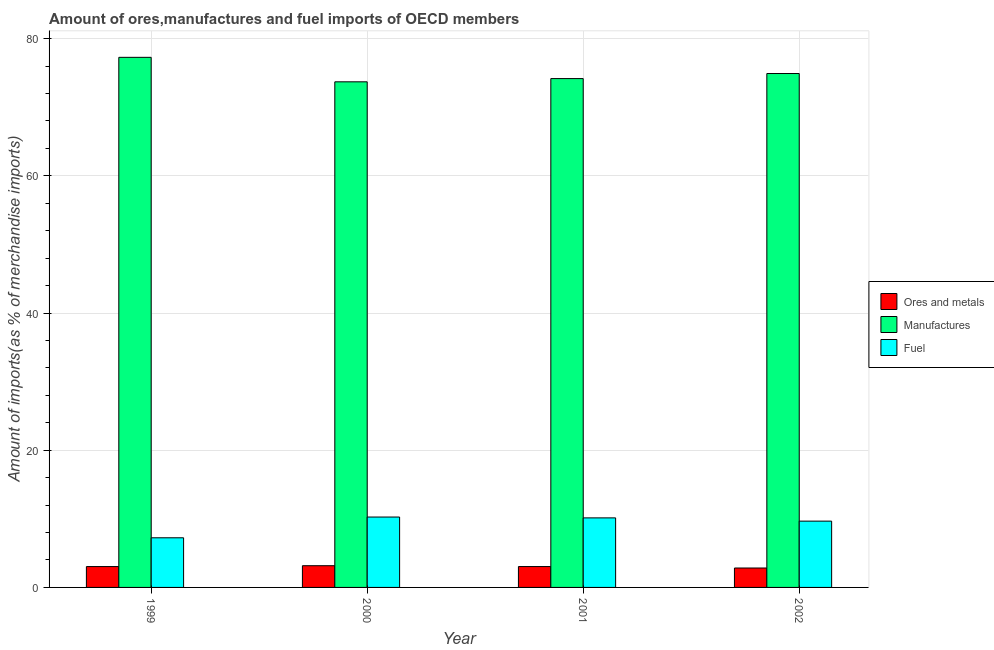How many groups of bars are there?
Offer a very short reply. 4. How many bars are there on the 4th tick from the left?
Give a very brief answer. 3. What is the label of the 2nd group of bars from the left?
Provide a short and direct response. 2000. What is the percentage of fuel imports in 2002?
Make the answer very short. 9.66. Across all years, what is the maximum percentage of manufactures imports?
Offer a terse response. 77.27. Across all years, what is the minimum percentage of manufactures imports?
Provide a short and direct response. 73.7. In which year was the percentage of ores and metals imports maximum?
Offer a terse response. 2000. In which year was the percentage of fuel imports minimum?
Give a very brief answer. 1999. What is the total percentage of manufactures imports in the graph?
Offer a very short reply. 300.05. What is the difference between the percentage of manufactures imports in 1999 and that in 2000?
Give a very brief answer. 3.57. What is the difference between the percentage of manufactures imports in 1999 and the percentage of fuel imports in 2000?
Provide a succinct answer. 3.57. What is the average percentage of manufactures imports per year?
Your answer should be very brief. 75.01. What is the ratio of the percentage of ores and metals imports in 2000 to that in 2001?
Ensure brevity in your answer.  1.04. What is the difference between the highest and the second highest percentage of fuel imports?
Give a very brief answer. 0.12. What is the difference between the highest and the lowest percentage of ores and metals imports?
Provide a succinct answer. 0.34. Is the sum of the percentage of manufactures imports in 2000 and 2001 greater than the maximum percentage of ores and metals imports across all years?
Provide a succinct answer. Yes. What does the 3rd bar from the left in 1999 represents?
Your response must be concise. Fuel. What does the 2nd bar from the right in 2002 represents?
Offer a terse response. Manufactures. How many bars are there?
Provide a succinct answer. 12. Are all the bars in the graph horizontal?
Keep it short and to the point. No. How many years are there in the graph?
Your response must be concise. 4. What is the difference between two consecutive major ticks on the Y-axis?
Provide a short and direct response. 20. Are the values on the major ticks of Y-axis written in scientific E-notation?
Your response must be concise. No. Does the graph contain grids?
Keep it short and to the point. Yes. Where does the legend appear in the graph?
Provide a short and direct response. Center right. What is the title of the graph?
Offer a very short reply. Amount of ores,manufactures and fuel imports of OECD members. Does "Renewable sources" appear as one of the legend labels in the graph?
Offer a very short reply. No. What is the label or title of the X-axis?
Your answer should be very brief. Year. What is the label or title of the Y-axis?
Provide a short and direct response. Amount of imports(as % of merchandise imports). What is the Amount of imports(as % of merchandise imports) of Ores and metals in 1999?
Provide a short and direct response. 3.04. What is the Amount of imports(as % of merchandise imports) of Manufactures in 1999?
Your answer should be compact. 77.27. What is the Amount of imports(as % of merchandise imports) of Fuel in 1999?
Ensure brevity in your answer.  7.24. What is the Amount of imports(as % of merchandise imports) in Ores and metals in 2000?
Ensure brevity in your answer.  3.17. What is the Amount of imports(as % of merchandise imports) in Manufactures in 2000?
Offer a very short reply. 73.7. What is the Amount of imports(as % of merchandise imports) of Fuel in 2000?
Offer a very short reply. 10.26. What is the Amount of imports(as % of merchandise imports) of Ores and metals in 2001?
Provide a short and direct response. 3.04. What is the Amount of imports(as % of merchandise imports) of Manufactures in 2001?
Your answer should be compact. 74.17. What is the Amount of imports(as % of merchandise imports) of Fuel in 2001?
Provide a succinct answer. 10.14. What is the Amount of imports(as % of merchandise imports) in Ores and metals in 2002?
Your answer should be very brief. 2.83. What is the Amount of imports(as % of merchandise imports) of Manufactures in 2002?
Give a very brief answer. 74.91. What is the Amount of imports(as % of merchandise imports) of Fuel in 2002?
Keep it short and to the point. 9.66. Across all years, what is the maximum Amount of imports(as % of merchandise imports) of Ores and metals?
Provide a succinct answer. 3.17. Across all years, what is the maximum Amount of imports(as % of merchandise imports) of Manufactures?
Keep it short and to the point. 77.27. Across all years, what is the maximum Amount of imports(as % of merchandise imports) of Fuel?
Ensure brevity in your answer.  10.26. Across all years, what is the minimum Amount of imports(as % of merchandise imports) in Ores and metals?
Provide a succinct answer. 2.83. Across all years, what is the minimum Amount of imports(as % of merchandise imports) in Manufactures?
Offer a terse response. 73.7. Across all years, what is the minimum Amount of imports(as % of merchandise imports) of Fuel?
Provide a short and direct response. 7.24. What is the total Amount of imports(as % of merchandise imports) of Ores and metals in the graph?
Keep it short and to the point. 12.08. What is the total Amount of imports(as % of merchandise imports) of Manufactures in the graph?
Your answer should be compact. 300.05. What is the total Amount of imports(as % of merchandise imports) of Fuel in the graph?
Keep it short and to the point. 37.29. What is the difference between the Amount of imports(as % of merchandise imports) in Ores and metals in 1999 and that in 2000?
Provide a succinct answer. -0.13. What is the difference between the Amount of imports(as % of merchandise imports) in Manufactures in 1999 and that in 2000?
Ensure brevity in your answer.  3.57. What is the difference between the Amount of imports(as % of merchandise imports) in Fuel in 1999 and that in 2000?
Offer a very short reply. -3.02. What is the difference between the Amount of imports(as % of merchandise imports) in Ores and metals in 1999 and that in 2001?
Make the answer very short. -0. What is the difference between the Amount of imports(as % of merchandise imports) in Manufactures in 1999 and that in 2001?
Your response must be concise. 3.1. What is the difference between the Amount of imports(as % of merchandise imports) in Fuel in 1999 and that in 2001?
Give a very brief answer. -2.9. What is the difference between the Amount of imports(as % of merchandise imports) of Ores and metals in 1999 and that in 2002?
Make the answer very short. 0.21. What is the difference between the Amount of imports(as % of merchandise imports) of Manufactures in 1999 and that in 2002?
Provide a succinct answer. 2.36. What is the difference between the Amount of imports(as % of merchandise imports) of Fuel in 1999 and that in 2002?
Offer a terse response. -2.43. What is the difference between the Amount of imports(as % of merchandise imports) of Ores and metals in 2000 and that in 2001?
Ensure brevity in your answer.  0.13. What is the difference between the Amount of imports(as % of merchandise imports) of Manufactures in 2000 and that in 2001?
Ensure brevity in your answer.  -0.47. What is the difference between the Amount of imports(as % of merchandise imports) of Fuel in 2000 and that in 2001?
Give a very brief answer. 0.12. What is the difference between the Amount of imports(as % of merchandise imports) of Ores and metals in 2000 and that in 2002?
Your answer should be very brief. 0.34. What is the difference between the Amount of imports(as % of merchandise imports) of Manufactures in 2000 and that in 2002?
Your answer should be compact. -1.21. What is the difference between the Amount of imports(as % of merchandise imports) in Fuel in 2000 and that in 2002?
Your answer should be compact. 0.6. What is the difference between the Amount of imports(as % of merchandise imports) in Ores and metals in 2001 and that in 2002?
Your answer should be very brief. 0.21. What is the difference between the Amount of imports(as % of merchandise imports) of Manufactures in 2001 and that in 2002?
Ensure brevity in your answer.  -0.74. What is the difference between the Amount of imports(as % of merchandise imports) in Fuel in 2001 and that in 2002?
Provide a short and direct response. 0.47. What is the difference between the Amount of imports(as % of merchandise imports) in Ores and metals in 1999 and the Amount of imports(as % of merchandise imports) in Manufactures in 2000?
Your response must be concise. -70.66. What is the difference between the Amount of imports(as % of merchandise imports) of Ores and metals in 1999 and the Amount of imports(as % of merchandise imports) of Fuel in 2000?
Give a very brief answer. -7.22. What is the difference between the Amount of imports(as % of merchandise imports) of Manufactures in 1999 and the Amount of imports(as % of merchandise imports) of Fuel in 2000?
Your response must be concise. 67.01. What is the difference between the Amount of imports(as % of merchandise imports) in Ores and metals in 1999 and the Amount of imports(as % of merchandise imports) in Manufactures in 2001?
Give a very brief answer. -71.13. What is the difference between the Amount of imports(as % of merchandise imports) in Ores and metals in 1999 and the Amount of imports(as % of merchandise imports) in Fuel in 2001?
Provide a short and direct response. -7.1. What is the difference between the Amount of imports(as % of merchandise imports) of Manufactures in 1999 and the Amount of imports(as % of merchandise imports) of Fuel in 2001?
Provide a short and direct response. 67.13. What is the difference between the Amount of imports(as % of merchandise imports) in Ores and metals in 1999 and the Amount of imports(as % of merchandise imports) in Manufactures in 2002?
Give a very brief answer. -71.87. What is the difference between the Amount of imports(as % of merchandise imports) in Ores and metals in 1999 and the Amount of imports(as % of merchandise imports) in Fuel in 2002?
Provide a succinct answer. -6.62. What is the difference between the Amount of imports(as % of merchandise imports) of Manufactures in 1999 and the Amount of imports(as % of merchandise imports) of Fuel in 2002?
Provide a short and direct response. 67.61. What is the difference between the Amount of imports(as % of merchandise imports) of Ores and metals in 2000 and the Amount of imports(as % of merchandise imports) of Manufactures in 2001?
Provide a short and direct response. -71. What is the difference between the Amount of imports(as % of merchandise imports) in Ores and metals in 2000 and the Amount of imports(as % of merchandise imports) in Fuel in 2001?
Your answer should be compact. -6.97. What is the difference between the Amount of imports(as % of merchandise imports) of Manufactures in 2000 and the Amount of imports(as % of merchandise imports) of Fuel in 2001?
Make the answer very short. 63.56. What is the difference between the Amount of imports(as % of merchandise imports) of Ores and metals in 2000 and the Amount of imports(as % of merchandise imports) of Manufactures in 2002?
Provide a succinct answer. -71.74. What is the difference between the Amount of imports(as % of merchandise imports) in Ores and metals in 2000 and the Amount of imports(as % of merchandise imports) in Fuel in 2002?
Your answer should be compact. -6.5. What is the difference between the Amount of imports(as % of merchandise imports) of Manufactures in 2000 and the Amount of imports(as % of merchandise imports) of Fuel in 2002?
Ensure brevity in your answer.  64.04. What is the difference between the Amount of imports(as % of merchandise imports) in Ores and metals in 2001 and the Amount of imports(as % of merchandise imports) in Manufactures in 2002?
Provide a short and direct response. -71.87. What is the difference between the Amount of imports(as % of merchandise imports) in Ores and metals in 2001 and the Amount of imports(as % of merchandise imports) in Fuel in 2002?
Your response must be concise. -6.62. What is the difference between the Amount of imports(as % of merchandise imports) of Manufactures in 2001 and the Amount of imports(as % of merchandise imports) of Fuel in 2002?
Keep it short and to the point. 64.51. What is the average Amount of imports(as % of merchandise imports) of Ores and metals per year?
Your response must be concise. 3.02. What is the average Amount of imports(as % of merchandise imports) in Manufactures per year?
Offer a terse response. 75.01. What is the average Amount of imports(as % of merchandise imports) in Fuel per year?
Ensure brevity in your answer.  9.32. In the year 1999, what is the difference between the Amount of imports(as % of merchandise imports) in Ores and metals and Amount of imports(as % of merchandise imports) in Manufactures?
Give a very brief answer. -74.23. In the year 1999, what is the difference between the Amount of imports(as % of merchandise imports) in Ores and metals and Amount of imports(as % of merchandise imports) in Fuel?
Provide a succinct answer. -4.2. In the year 1999, what is the difference between the Amount of imports(as % of merchandise imports) of Manufactures and Amount of imports(as % of merchandise imports) of Fuel?
Provide a short and direct response. 70.03. In the year 2000, what is the difference between the Amount of imports(as % of merchandise imports) of Ores and metals and Amount of imports(as % of merchandise imports) of Manufactures?
Keep it short and to the point. -70.53. In the year 2000, what is the difference between the Amount of imports(as % of merchandise imports) in Ores and metals and Amount of imports(as % of merchandise imports) in Fuel?
Offer a terse response. -7.09. In the year 2000, what is the difference between the Amount of imports(as % of merchandise imports) in Manufactures and Amount of imports(as % of merchandise imports) in Fuel?
Your response must be concise. 63.44. In the year 2001, what is the difference between the Amount of imports(as % of merchandise imports) of Ores and metals and Amount of imports(as % of merchandise imports) of Manufactures?
Offer a very short reply. -71.13. In the year 2001, what is the difference between the Amount of imports(as % of merchandise imports) in Ores and metals and Amount of imports(as % of merchandise imports) in Fuel?
Offer a very short reply. -7.1. In the year 2001, what is the difference between the Amount of imports(as % of merchandise imports) in Manufactures and Amount of imports(as % of merchandise imports) in Fuel?
Provide a short and direct response. 64.03. In the year 2002, what is the difference between the Amount of imports(as % of merchandise imports) of Ores and metals and Amount of imports(as % of merchandise imports) of Manufactures?
Offer a very short reply. -72.08. In the year 2002, what is the difference between the Amount of imports(as % of merchandise imports) of Ores and metals and Amount of imports(as % of merchandise imports) of Fuel?
Offer a terse response. -6.83. In the year 2002, what is the difference between the Amount of imports(as % of merchandise imports) of Manufactures and Amount of imports(as % of merchandise imports) of Fuel?
Your answer should be compact. 65.25. What is the ratio of the Amount of imports(as % of merchandise imports) in Ores and metals in 1999 to that in 2000?
Provide a succinct answer. 0.96. What is the ratio of the Amount of imports(as % of merchandise imports) of Manufactures in 1999 to that in 2000?
Your answer should be very brief. 1.05. What is the ratio of the Amount of imports(as % of merchandise imports) of Fuel in 1999 to that in 2000?
Offer a very short reply. 0.71. What is the ratio of the Amount of imports(as % of merchandise imports) of Ores and metals in 1999 to that in 2001?
Ensure brevity in your answer.  1. What is the ratio of the Amount of imports(as % of merchandise imports) in Manufactures in 1999 to that in 2001?
Your answer should be very brief. 1.04. What is the ratio of the Amount of imports(as % of merchandise imports) of Fuel in 1999 to that in 2001?
Offer a very short reply. 0.71. What is the ratio of the Amount of imports(as % of merchandise imports) in Ores and metals in 1999 to that in 2002?
Your answer should be very brief. 1.07. What is the ratio of the Amount of imports(as % of merchandise imports) in Manufactures in 1999 to that in 2002?
Your answer should be very brief. 1.03. What is the ratio of the Amount of imports(as % of merchandise imports) in Fuel in 1999 to that in 2002?
Offer a terse response. 0.75. What is the ratio of the Amount of imports(as % of merchandise imports) of Ores and metals in 2000 to that in 2001?
Keep it short and to the point. 1.04. What is the ratio of the Amount of imports(as % of merchandise imports) in Manufactures in 2000 to that in 2001?
Make the answer very short. 0.99. What is the ratio of the Amount of imports(as % of merchandise imports) in Fuel in 2000 to that in 2001?
Offer a very short reply. 1.01. What is the ratio of the Amount of imports(as % of merchandise imports) of Ores and metals in 2000 to that in 2002?
Your response must be concise. 1.12. What is the ratio of the Amount of imports(as % of merchandise imports) of Manufactures in 2000 to that in 2002?
Your answer should be very brief. 0.98. What is the ratio of the Amount of imports(as % of merchandise imports) in Fuel in 2000 to that in 2002?
Ensure brevity in your answer.  1.06. What is the ratio of the Amount of imports(as % of merchandise imports) in Ores and metals in 2001 to that in 2002?
Provide a succinct answer. 1.07. What is the ratio of the Amount of imports(as % of merchandise imports) in Fuel in 2001 to that in 2002?
Provide a short and direct response. 1.05. What is the difference between the highest and the second highest Amount of imports(as % of merchandise imports) in Ores and metals?
Make the answer very short. 0.13. What is the difference between the highest and the second highest Amount of imports(as % of merchandise imports) in Manufactures?
Make the answer very short. 2.36. What is the difference between the highest and the second highest Amount of imports(as % of merchandise imports) in Fuel?
Ensure brevity in your answer.  0.12. What is the difference between the highest and the lowest Amount of imports(as % of merchandise imports) in Ores and metals?
Provide a succinct answer. 0.34. What is the difference between the highest and the lowest Amount of imports(as % of merchandise imports) in Manufactures?
Keep it short and to the point. 3.57. What is the difference between the highest and the lowest Amount of imports(as % of merchandise imports) in Fuel?
Give a very brief answer. 3.02. 